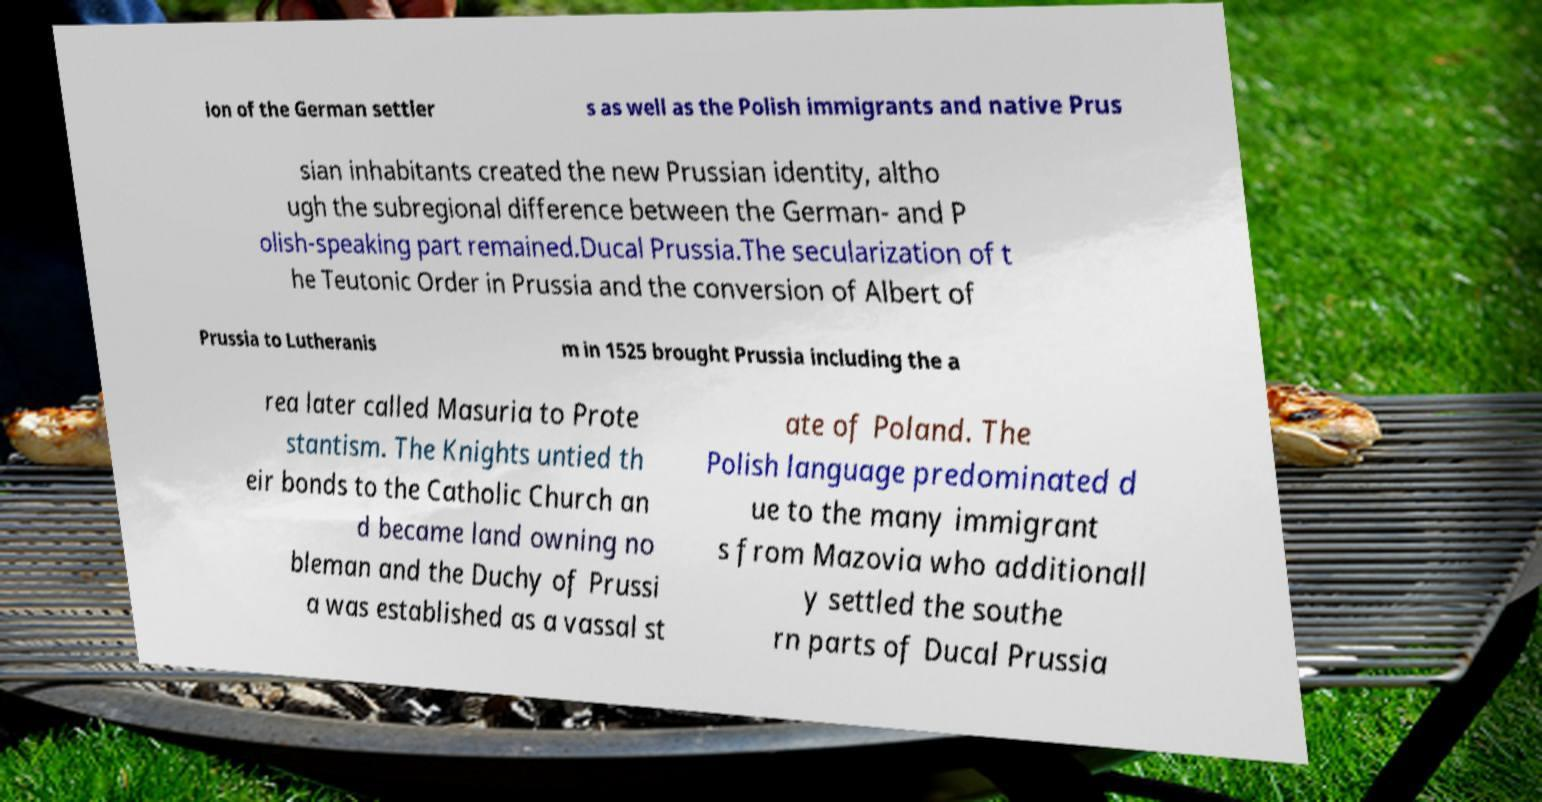There's text embedded in this image that I need extracted. Can you transcribe it verbatim? ion of the German settler s as well as the Polish immigrants and native Prus sian inhabitants created the new Prussian identity, altho ugh the subregional difference between the German- and P olish-speaking part remained.Ducal Prussia.The secularization of t he Teutonic Order in Prussia and the conversion of Albert of Prussia to Lutheranis m in 1525 brought Prussia including the a rea later called Masuria to Prote stantism. The Knights untied th eir bonds to the Catholic Church an d became land owning no bleman and the Duchy of Prussi a was established as a vassal st ate of Poland. The Polish language predominated d ue to the many immigrant s from Mazovia who additionall y settled the southe rn parts of Ducal Prussia 